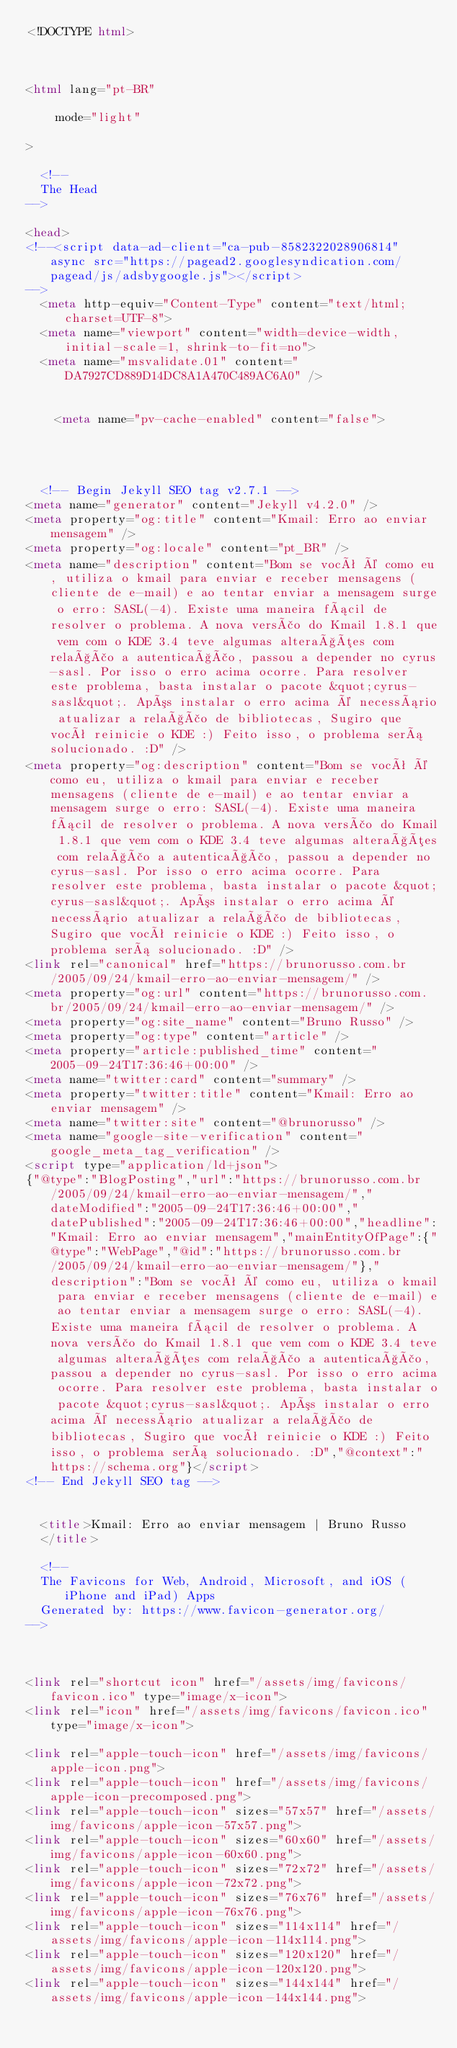Convert code to text. <code><loc_0><loc_0><loc_500><loc_500><_HTML_><!DOCTYPE html>



<html lang="pt-BR" 
  
    mode="light"
  
>

  <!--
  The Head
-->

<head>
<!--<script data-ad-client="ca-pub-8582322028906814" async src="https://pagead2.googlesyndication.com/pagead/js/adsbygoogle.js"></script>
-->
  <meta http-equiv="Content-Type" content="text/html; charset=UTF-8">
  <meta name="viewport" content="width=device-width, initial-scale=1, shrink-to-fit=no">
  <meta name="msvalidate.01" content="DA7927CD889D14DC8A1A470C489AC6A0" />

  
    <meta name="pv-cache-enabled" content="false">

    
  

  <!-- Begin Jekyll SEO tag v2.7.1 -->
<meta name="generator" content="Jekyll v4.2.0" />
<meta property="og:title" content="Kmail: Erro ao enviar mensagem" />
<meta property="og:locale" content="pt_BR" />
<meta name="description" content="Bom se você é como eu, utiliza o kmail para enviar e receber mensagens (cliente de e-mail) e ao tentar enviar a mensagem surge o erro: SASL(-4). Existe uma maneira fácil de resolver o problema. A nova versão do Kmail 1.8.1 que vem com o KDE 3.4 teve algumas alterações com relação a autenticação, passou a depender no cyrus-sasl. Por isso o erro acima ocorre. Para resolver este problema, basta instalar o pacote &quot;cyrus-sasl&quot;. Após instalar o erro acima é necessário atualizar a relação de bibliotecas, Sugiro que você reinicie o KDE :) Feito isso, o problema será solucionado. :D" />
<meta property="og:description" content="Bom se você é como eu, utiliza o kmail para enviar e receber mensagens (cliente de e-mail) e ao tentar enviar a mensagem surge o erro: SASL(-4). Existe uma maneira fácil de resolver o problema. A nova versão do Kmail 1.8.1 que vem com o KDE 3.4 teve algumas alterações com relação a autenticação, passou a depender no cyrus-sasl. Por isso o erro acima ocorre. Para resolver este problema, basta instalar o pacote &quot;cyrus-sasl&quot;. Após instalar o erro acima é necessário atualizar a relação de bibliotecas, Sugiro que você reinicie o KDE :) Feito isso, o problema será solucionado. :D" />
<link rel="canonical" href="https://brunorusso.com.br/2005/09/24/kmail-erro-ao-enviar-mensagem/" />
<meta property="og:url" content="https://brunorusso.com.br/2005/09/24/kmail-erro-ao-enviar-mensagem/" />
<meta property="og:site_name" content="Bruno Russo" />
<meta property="og:type" content="article" />
<meta property="article:published_time" content="2005-09-24T17:36:46+00:00" />
<meta name="twitter:card" content="summary" />
<meta property="twitter:title" content="Kmail: Erro ao enviar mensagem" />
<meta name="twitter:site" content="@brunorusso" />
<meta name="google-site-verification" content="google_meta_tag_verification" />
<script type="application/ld+json">
{"@type":"BlogPosting","url":"https://brunorusso.com.br/2005/09/24/kmail-erro-ao-enviar-mensagem/","dateModified":"2005-09-24T17:36:46+00:00","datePublished":"2005-09-24T17:36:46+00:00","headline":"Kmail: Erro ao enviar mensagem","mainEntityOfPage":{"@type":"WebPage","@id":"https://brunorusso.com.br/2005/09/24/kmail-erro-ao-enviar-mensagem/"},"description":"Bom se você é como eu, utiliza o kmail para enviar e receber mensagens (cliente de e-mail) e ao tentar enviar a mensagem surge o erro: SASL(-4). Existe uma maneira fácil de resolver o problema. A nova versão do Kmail 1.8.1 que vem com o KDE 3.4 teve algumas alterações com relação a autenticação, passou a depender no cyrus-sasl. Por isso o erro acima ocorre. Para resolver este problema, basta instalar o pacote &quot;cyrus-sasl&quot;. Após instalar o erro acima é necessário atualizar a relação de bibliotecas, Sugiro que você reinicie o KDE :) Feito isso, o problema será solucionado. :D","@context":"https://schema.org"}</script>
<!-- End Jekyll SEO tag -->


  <title>Kmail: Erro ao enviar mensagem | Bruno Russo
  </title>

  <!--
  The Favicons for Web, Android, Microsoft, and iOS (iPhone and iPad) Apps
  Generated by: https://www.favicon-generator.org/
-->



<link rel="shortcut icon" href="/assets/img/favicons/favicon.ico" type="image/x-icon">
<link rel="icon" href="/assets/img/favicons/favicon.ico" type="image/x-icon">

<link rel="apple-touch-icon" href="/assets/img/favicons/apple-icon.png">
<link rel="apple-touch-icon" href="/assets/img/favicons/apple-icon-precomposed.png">
<link rel="apple-touch-icon" sizes="57x57" href="/assets/img/favicons/apple-icon-57x57.png">
<link rel="apple-touch-icon" sizes="60x60" href="/assets/img/favicons/apple-icon-60x60.png">
<link rel="apple-touch-icon" sizes="72x72" href="/assets/img/favicons/apple-icon-72x72.png">
<link rel="apple-touch-icon" sizes="76x76" href="/assets/img/favicons/apple-icon-76x76.png">
<link rel="apple-touch-icon" sizes="114x114" href="/assets/img/favicons/apple-icon-114x114.png">
<link rel="apple-touch-icon" sizes="120x120" href="/assets/img/favicons/apple-icon-120x120.png">
<link rel="apple-touch-icon" sizes="144x144" href="/assets/img/favicons/apple-icon-144x144.png"></code> 